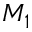<formula> <loc_0><loc_0><loc_500><loc_500>M _ { 1 }</formula> 